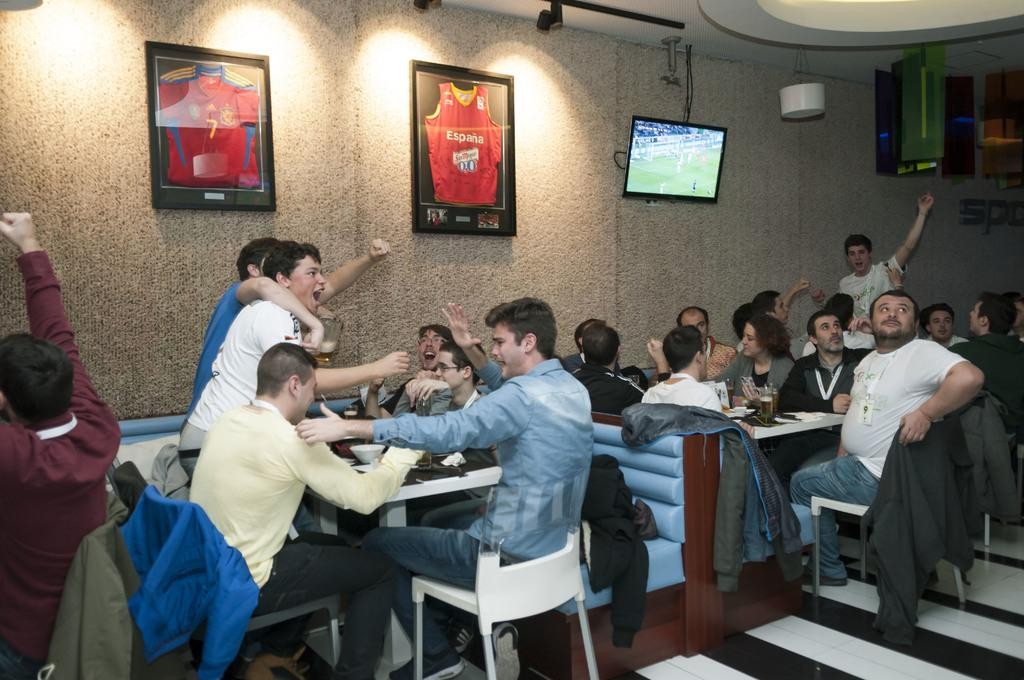How many people are in the image? There is a group of people in the image. What are the people doing in the image? The people are sitting on chairs. Where are the chairs located in relation to the table? The chairs are in front of a table. What is on the wall in the image? There is a TV and a wall photo on the wall. What can be seen on the table in the image? There are objects on the table. What type of need is being used to sew the top of the table in the image? There is no need or sewing activity present in the image. The table has objects on it, but no sewing or top-related activity is depicted. 